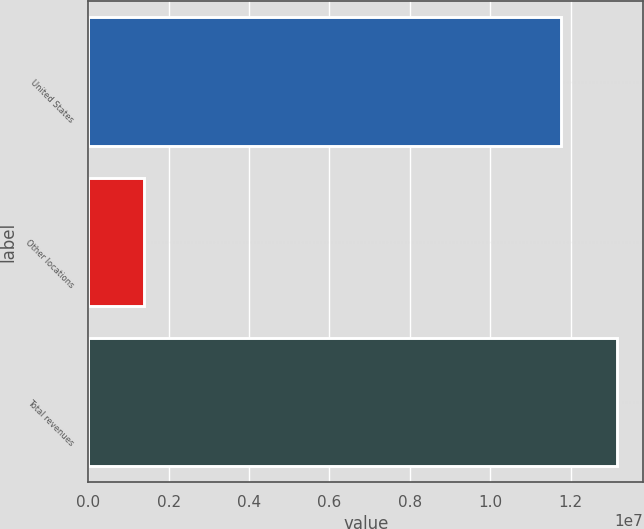<chart> <loc_0><loc_0><loc_500><loc_500><bar_chart><fcel>United States<fcel>Other locations<fcel>Total revenues<nl><fcel>1.17496e+07<fcel>1.39481e+06<fcel>1.31444e+07<nl></chart> 